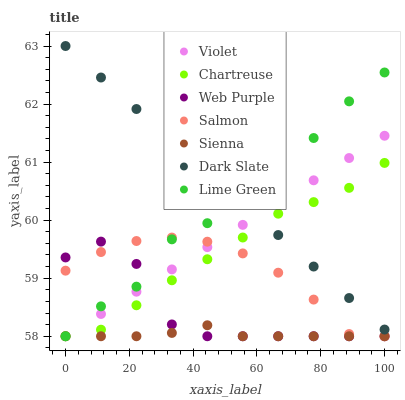Does Sienna have the minimum area under the curve?
Answer yes or no. Yes. Does Dark Slate have the maximum area under the curve?
Answer yes or no. Yes. Does Web Purple have the minimum area under the curve?
Answer yes or no. No. Does Web Purple have the maximum area under the curve?
Answer yes or no. No. Is Dark Slate the smoothest?
Answer yes or no. Yes. Is Web Purple the roughest?
Answer yes or no. Yes. Is Sienna the smoothest?
Answer yes or no. No. Is Sienna the roughest?
Answer yes or no. No. Does Salmon have the lowest value?
Answer yes or no. Yes. Does Dark Slate have the lowest value?
Answer yes or no. No. Does Dark Slate have the highest value?
Answer yes or no. Yes. Does Web Purple have the highest value?
Answer yes or no. No. Is Web Purple less than Dark Slate?
Answer yes or no. Yes. Is Dark Slate greater than Sienna?
Answer yes or no. Yes. Does Lime Green intersect Sienna?
Answer yes or no. Yes. Is Lime Green less than Sienna?
Answer yes or no. No. Is Lime Green greater than Sienna?
Answer yes or no. No. Does Web Purple intersect Dark Slate?
Answer yes or no. No. 